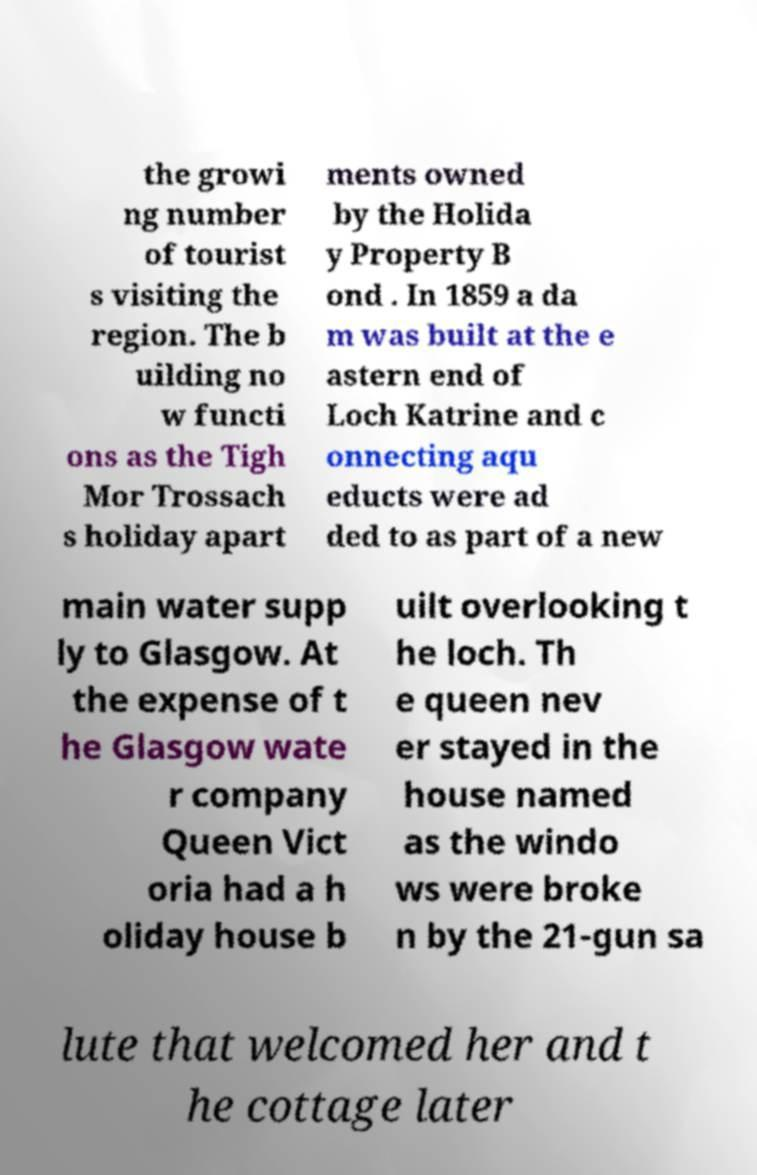There's text embedded in this image that I need extracted. Can you transcribe it verbatim? the growi ng number of tourist s visiting the region. The b uilding no w functi ons as the Tigh Mor Trossach s holiday apart ments owned by the Holida y Property B ond . In 1859 a da m was built at the e astern end of Loch Katrine and c onnecting aqu educts were ad ded to as part of a new main water supp ly to Glasgow. At the expense of t he Glasgow wate r company Queen Vict oria had a h oliday house b uilt overlooking t he loch. Th e queen nev er stayed in the house named as the windo ws were broke n by the 21-gun sa lute that welcomed her and t he cottage later 